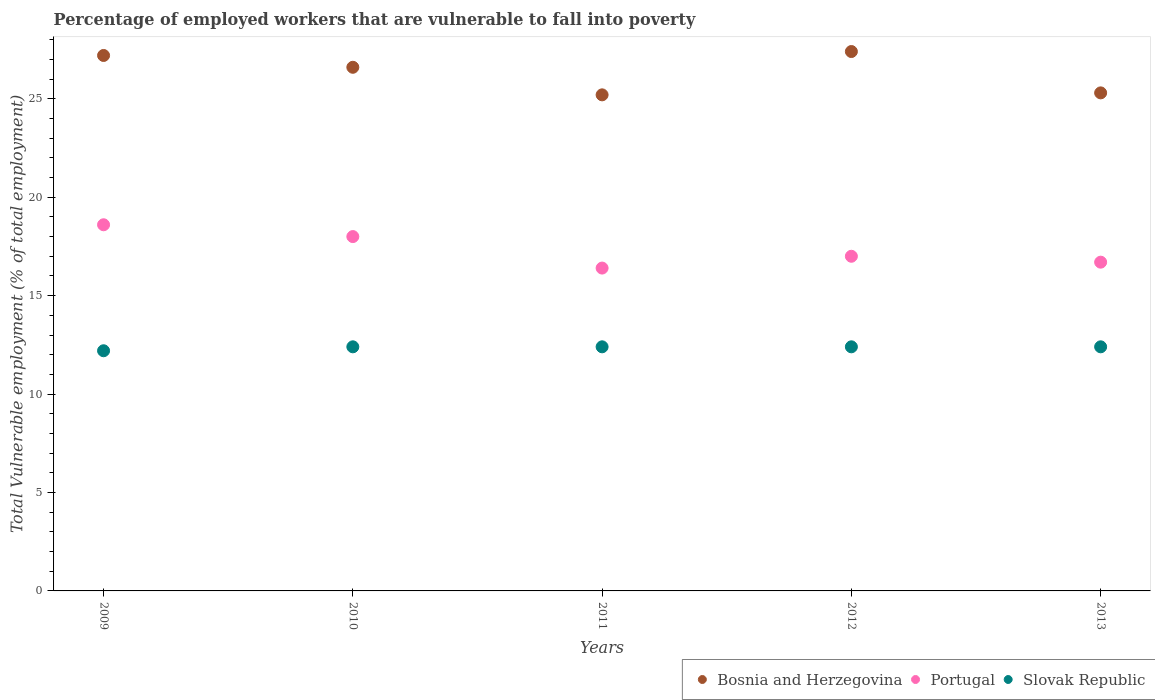How many different coloured dotlines are there?
Your answer should be compact. 3. Is the number of dotlines equal to the number of legend labels?
Give a very brief answer. Yes. What is the percentage of employed workers who are vulnerable to fall into poverty in Bosnia and Herzegovina in 2010?
Provide a succinct answer. 26.6. Across all years, what is the maximum percentage of employed workers who are vulnerable to fall into poverty in Portugal?
Keep it short and to the point. 18.6. Across all years, what is the minimum percentage of employed workers who are vulnerable to fall into poverty in Slovak Republic?
Offer a very short reply. 12.2. In which year was the percentage of employed workers who are vulnerable to fall into poverty in Slovak Republic minimum?
Your response must be concise. 2009. What is the total percentage of employed workers who are vulnerable to fall into poverty in Slovak Republic in the graph?
Your answer should be very brief. 61.8. What is the difference between the percentage of employed workers who are vulnerable to fall into poverty in Bosnia and Herzegovina in 2012 and that in 2013?
Make the answer very short. 2.1. What is the difference between the percentage of employed workers who are vulnerable to fall into poverty in Slovak Republic in 2010 and the percentage of employed workers who are vulnerable to fall into poverty in Portugal in 2009?
Make the answer very short. -6.2. What is the average percentage of employed workers who are vulnerable to fall into poverty in Bosnia and Herzegovina per year?
Your response must be concise. 26.34. In the year 2010, what is the difference between the percentage of employed workers who are vulnerable to fall into poverty in Portugal and percentage of employed workers who are vulnerable to fall into poverty in Bosnia and Herzegovina?
Your answer should be very brief. -8.6. What is the ratio of the percentage of employed workers who are vulnerable to fall into poverty in Slovak Republic in 2012 to that in 2013?
Keep it short and to the point. 1. What is the difference between the highest and the second highest percentage of employed workers who are vulnerable to fall into poverty in Bosnia and Herzegovina?
Keep it short and to the point. 0.2. What is the difference between the highest and the lowest percentage of employed workers who are vulnerable to fall into poverty in Bosnia and Herzegovina?
Make the answer very short. 2.2. In how many years, is the percentage of employed workers who are vulnerable to fall into poverty in Portugal greater than the average percentage of employed workers who are vulnerable to fall into poverty in Portugal taken over all years?
Give a very brief answer. 2. Is the sum of the percentage of employed workers who are vulnerable to fall into poverty in Slovak Republic in 2012 and 2013 greater than the maximum percentage of employed workers who are vulnerable to fall into poverty in Portugal across all years?
Your answer should be very brief. Yes. Is it the case that in every year, the sum of the percentage of employed workers who are vulnerable to fall into poverty in Bosnia and Herzegovina and percentage of employed workers who are vulnerable to fall into poverty in Slovak Republic  is greater than the percentage of employed workers who are vulnerable to fall into poverty in Portugal?
Your answer should be compact. Yes. How many dotlines are there?
Provide a succinct answer. 3. How many legend labels are there?
Your response must be concise. 3. How are the legend labels stacked?
Your answer should be very brief. Horizontal. What is the title of the graph?
Your answer should be compact. Percentage of employed workers that are vulnerable to fall into poverty. What is the label or title of the Y-axis?
Your answer should be compact. Total Vulnerable employment (% of total employment). What is the Total Vulnerable employment (% of total employment) in Bosnia and Herzegovina in 2009?
Your answer should be compact. 27.2. What is the Total Vulnerable employment (% of total employment) of Portugal in 2009?
Make the answer very short. 18.6. What is the Total Vulnerable employment (% of total employment) of Slovak Republic in 2009?
Your answer should be compact. 12.2. What is the Total Vulnerable employment (% of total employment) in Bosnia and Herzegovina in 2010?
Ensure brevity in your answer.  26.6. What is the Total Vulnerable employment (% of total employment) of Portugal in 2010?
Your answer should be very brief. 18. What is the Total Vulnerable employment (% of total employment) of Slovak Republic in 2010?
Provide a short and direct response. 12.4. What is the Total Vulnerable employment (% of total employment) in Bosnia and Herzegovina in 2011?
Provide a succinct answer. 25.2. What is the Total Vulnerable employment (% of total employment) of Portugal in 2011?
Give a very brief answer. 16.4. What is the Total Vulnerable employment (% of total employment) in Slovak Republic in 2011?
Offer a terse response. 12.4. What is the Total Vulnerable employment (% of total employment) in Bosnia and Herzegovina in 2012?
Keep it short and to the point. 27.4. What is the Total Vulnerable employment (% of total employment) in Slovak Republic in 2012?
Ensure brevity in your answer.  12.4. What is the Total Vulnerable employment (% of total employment) of Bosnia and Herzegovina in 2013?
Offer a terse response. 25.3. What is the Total Vulnerable employment (% of total employment) in Portugal in 2013?
Ensure brevity in your answer.  16.7. What is the Total Vulnerable employment (% of total employment) in Slovak Republic in 2013?
Offer a very short reply. 12.4. Across all years, what is the maximum Total Vulnerable employment (% of total employment) in Bosnia and Herzegovina?
Ensure brevity in your answer.  27.4. Across all years, what is the maximum Total Vulnerable employment (% of total employment) of Portugal?
Keep it short and to the point. 18.6. Across all years, what is the maximum Total Vulnerable employment (% of total employment) in Slovak Republic?
Provide a succinct answer. 12.4. Across all years, what is the minimum Total Vulnerable employment (% of total employment) of Bosnia and Herzegovina?
Ensure brevity in your answer.  25.2. Across all years, what is the minimum Total Vulnerable employment (% of total employment) of Portugal?
Your response must be concise. 16.4. Across all years, what is the minimum Total Vulnerable employment (% of total employment) of Slovak Republic?
Offer a very short reply. 12.2. What is the total Total Vulnerable employment (% of total employment) in Bosnia and Herzegovina in the graph?
Ensure brevity in your answer.  131.7. What is the total Total Vulnerable employment (% of total employment) of Portugal in the graph?
Provide a short and direct response. 86.7. What is the total Total Vulnerable employment (% of total employment) in Slovak Republic in the graph?
Your answer should be compact. 61.8. What is the difference between the Total Vulnerable employment (% of total employment) in Bosnia and Herzegovina in 2009 and that in 2010?
Keep it short and to the point. 0.6. What is the difference between the Total Vulnerable employment (% of total employment) of Portugal in 2009 and that in 2010?
Your response must be concise. 0.6. What is the difference between the Total Vulnerable employment (% of total employment) of Slovak Republic in 2009 and that in 2010?
Ensure brevity in your answer.  -0.2. What is the difference between the Total Vulnerable employment (% of total employment) of Bosnia and Herzegovina in 2009 and that in 2012?
Keep it short and to the point. -0.2. What is the difference between the Total Vulnerable employment (% of total employment) of Portugal in 2009 and that in 2012?
Provide a succinct answer. 1.6. What is the difference between the Total Vulnerable employment (% of total employment) of Slovak Republic in 2009 and that in 2012?
Provide a succinct answer. -0.2. What is the difference between the Total Vulnerable employment (% of total employment) of Bosnia and Herzegovina in 2009 and that in 2013?
Your answer should be very brief. 1.9. What is the difference between the Total Vulnerable employment (% of total employment) in Portugal in 2009 and that in 2013?
Your answer should be very brief. 1.9. What is the difference between the Total Vulnerable employment (% of total employment) in Slovak Republic in 2009 and that in 2013?
Provide a succinct answer. -0.2. What is the difference between the Total Vulnerable employment (% of total employment) of Bosnia and Herzegovina in 2010 and that in 2011?
Offer a terse response. 1.4. What is the difference between the Total Vulnerable employment (% of total employment) in Slovak Republic in 2010 and that in 2011?
Offer a very short reply. 0. What is the difference between the Total Vulnerable employment (% of total employment) of Portugal in 2010 and that in 2012?
Offer a very short reply. 1. What is the difference between the Total Vulnerable employment (% of total employment) in Bosnia and Herzegovina in 2010 and that in 2013?
Ensure brevity in your answer.  1.3. What is the difference between the Total Vulnerable employment (% of total employment) of Slovak Republic in 2010 and that in 2013?
Offer a very short reply. 0. What is the difference between the Total Vulnerable employment (% of total employment) of Portugal in 2011 and that in 2013?
Provide a short and direct response. -0.3. What is the difference between the Total Vulnerable employment (% of total employment) of Slovak Republic in 2011 and that in 2013?
Provide a succinct answer. 0. What is the difference between the Total Vulnerable employment (% of total employment) in Bosnia and Herzegovina in 2012 and that in 2013?
Provide a succinct answer. 2.1. What is the difference between the Total Vulnerable employment (% of total employment) in Slovak Republic in 2012 and that in 2013?
Ensure brevity in your answer.  0. What is the difference between the Total Vulnerable employment (% of total employment) in Bosnia and Herzegovina in 2009 and the Total Vulnerable employment (% of total employment) in Slovak Republic in 2010?
Offer a terse response. 14.8. What is the difference between the Total Vulnerable employment (% of total employment) in Portugal in 2009 and the Total Vulnerable employment (% of total employment) in Slovak Republic in 2010?
Your answer should be very brief. 6.2. What is the difference between the Total Vulnerable employment (% of total employment) of Bosnia and Herzegovina in 2009 and the Total Vulnerable employment (% of total employment) of Portugal in 2011?
Your response must be concise. 10.8. What is the difference between the Total Vulnerable employment (% of total employment) of Bosnia and Herzegovina in 2009 and the Total Vulnerable employment (% of total employment) of Slovak Republic in 2011?
Your answer should be compact. 14.8. What is the difference between the Total Vulnerable employment (% of total employment) in Portugal in 2009 and the Total Vulnerable employment (% of total employment) in Slovak Republic in 2011?
Your answer should be compact. 6.2. What is the difference between the Total Vulnerable employment (% of total employment) in Portugal in 2009 and the Total Vulnerable employment (% of total employment) in Slovak Republic in 2012?
Your answer should be very brief. 6.2. What is the difference between the Total Vulnerable employment (% of total employment) in Bosnia and Herzegovina in 2009 and the Total Vulnerable employment (% of total employment) in Slovak Republic in 2013?
Your answer should be very brief. 14.8. What is the difference between the Total Vulnerable employment (% of total employment) in Bosnia and Herzegovina in 2010 and the Total Vulnerable employment (% of total employment) in Slovak Republic in 2011?
Your response must be concise. 14.2. What is the difference between the Total Vulnerable employment (% of total employment) in Bosnia and Herzegovina in 2010 and the Total Vulnerable employment (% of total employment) in Portugal in 2012?
Provide a short and direct response. 9.6. What is the difference between the Total Vulnerable employment (% of total employment) of Bosnia and Herzegovina in 2010 and the Total Vulnerable employment (% of total employment) of Slovak Republic in 2012?
Ensure brevity in your answer.  14.2. What is the difference between the Total Vulnerable employment (% of total employment) in Bosnia and Herzegovina in 2011 and the Total Vulnerable employment (% of total employment) in Portugal in 2012?
Your answer should be very brief. 8.2. What is the difference between the Total Vulnerable employment (% of total employment) of Bosnia and Herzegovina in 2011 and the Total Vulnerable employment (% of total employment) of Slovak Republic in 2013?
Offer a terse response. 12.8. What is the difference between the Total Vulnerable employment (% of total employment) in Portugal in 2011 and the Total Vulnerable employment (% of total employment) in Slovak Republic in 2013?
Your answer should be compact. 4. What is the difference between the Total Vulnerable employment (% of total employment) in Portugal in 2012 and the Total Vulnerable employment (% of total employment) in Slovak Republic in 2013?
Your answer should be very brief. 4.6. What is the average Total Vulnerable employment (% of total employment) of Bosnia and Herzegovina per year?
Your response must be concise. 26.34. What is the average Total Vulnerable employment (% of total employment) in Portugal per year?
Your answer should be very brief. 17.34. What is the average Total Vulnerable employment (% of total employment) in Slovak Republic per year?
Your answer should be compact. 12.36. In the year 2009, what is the difference between the Total Vulnerable employment (% of total employment) in Bosnia and Herzegovina and Total Vulnerable employment (% of total employment) in Portugal?
Offer a terse response. 8.6. In the year 2009, what is the difference between the Total Vulnerable employment (% of total employment) in Portugal and Total Vulnerable employment (% of total employment) in Slovak Republic?
Give a very brief answer. 6.4. In the year 2010, what is the difference between the Total Vulnerable employment (% of total employment) of Bosnia and Herzegovina and Total Vulnerable employment (% of total employment) of Slovak Republic?
Offer a very short reply. 14.2. In the year 2011, what is the difference between the Total Vulnerable employment (% of total employment) in Bosnia and Herzegovina and Total Vulnerable employment (% of total employment) in Portugal?
Your answer should be very brief. 8.8. In the year 2011, what is the difference between the Total Vulnerable employment (% of total employment) in Bosnia and Herzegovina and Total Vulnerable employment (% of total employment) in Slovak Republic?
Ensure brevity in your answer.  12.8. In the year 2011, what is the difference between the Total Vulnerable employment (% of total employment) of Portugal and Total Vulnerable employment (% of total employment) of Slovak Republic?
Your response must be concise. 4. In the year 2012, what is the difference between the Total Vulnerable employment (% of total employment) in Bosnia and Herzegovina and Total Vulnerable employment (% of total employment) in Slovak Republic?
Give a very brief answer. 15. In the year 2013, what is the difference between the Total Vulnerable employment (% of total employment) of Bosnia and Herzegovina and Total Vulnerable employment (% of total employment) of Slovak Republic?
Keep it short and to the point. 12.9. What is the ratio of the Total Vulnerable employment (% of total employment) in Bosnia and Herzegovina in 2009 to that in 2010?
Ensure brevity in your answer.  1.02. What is the ratio of the Total Vulnerable employment (% of total employment) of Slovak Republic in 2009 to that in 2010?
Ensure brevity in your answer.  0.98. What is the ratio of the Total Vulnerable employment (% of total employment) of Bosnia and Herzegovina in 2009 to that in 2011?
Make the answer very short. 1.08. What is the ratio of the Total Vulnerable employment (% of total employment) in Portugal in 2009 to that in 2011?
Give a very brief answer. 1.13. What is the ratio of the Total Vulnerable employment (% of total employment) of Slovak Republic in 2009 to that in 2011?
Offer a very short reply. 0.98. What is the ratio of the Total Vulnerable employment (% of total employment) of Portugal in 2009 to that in 2012?
Your answer should be compact. 1.09. What is the ratio of the Total Vulnerable employment (% of total employment) of Slovak Republic in 2009 to that in 2012?
Keep it short and to the point. 0.98. What is the ratio of the Total Vulnerable employment (% of total employment) of Bosnia and Herzegovina in 2009 to that in 2013?
Keep it short and to the point. 1.08. What is the ratio of the Total Vulnerable employment (% of total employment) in Portugal in 2009 to that in 2013?
Offer a very short reply. 1.11. What is the ratio of the Total Vulnerable employment (% of total employment) of Slovak Republic in 2009 to that in 2013?
Offer a very short reply. 0.98. What is the ratio of the Total Vulnerable employment (% of total employment) of Bosnia and Herzegovina in 2010 to that in 2011?
Make the answer very short. 1.06. What is the ratio of the Total Vulnerable employment (% of total employment) of Portugal in 2010 to that in 2011?
Provide a succinct answer. 1.1. What is the ratio of the Total Vulnerable employment (% of total employment) in Slovak Republic in 2010 to that in 2011?
Your answer should be very brief. 1. What is the ratio of the Total Vulnerable employment (% of total employment) of Bosnia and Herzegovina in 2010 to that in 2012?
Provide a short and direct response. 0.97. What is the ratio of the Total Vulnerable employment (% of total employment) in Portugal in 2010 to that in 2012?
Provide a succinct answer. 1.06. What is the ratio of the Total Vulnerable employment (% of total employment) of Slovak Republic in 2010 to that in 2012?
Offer a terse response. 1. What is the ratio of the Total Vulnerable employment (% of total employment) of Bosnia and Herzegovina in 2010 to that in 2013?
Provide a short and direct response. 1.05. What is the ratio of the Total Vulnerable employment (% of total employment) of Portugal in 2010 to that in 2013?
Your response must be concise. 1.08. What is the ratio of the Total Vulnerable employment (% of total employment) in Bosnia and Herzegovina in 2011 to that in 2012?
Keep it short and to the point. 0.92. What is the ratio of the Total Vulnerable employment (% of total employment) in Portugal in 2011 to that in 2012?
Your answer should be compact. 0.96. What is the ratio of the Total Vulnerable employment (% of total employment) of Bosnia and Herzegovina in 2011 to that in 2013?
Offer a very short reply. 1. What is the ratio of the Total Vulnerable employment (% of total employment) of Portugal in 2011 to that in 2013?
Offer a terse response. 0.98. What is the ratio of the Total Vulnerable employment (% of total employment) of Bosnia and Herzegovina in 2012 to that in 2013?
Ensure brevity in your answer.  1.08. What is the ratio of the Total Vulnerable employment (% of total employment) of Portugal in 2012 to that in 2013?
Your response must be concise. 1.02. What is the difference between the highest and the second highest Total Vulnerable employment (% of total employment) in Portugal?
Provide a succinct answer. 0.6. What is the difference between the highest and the second highest Total Vulnerable employment (% of total employment) of Slovak Republic?
Offer a terse response. 0. What is the difference between the highest and the lowest Total Vulnerable employment (% of total employment) of Portugal?
Offer a very short reply. 2.2. What is the difference between the highest and the lowest Total Vulnerable employment (% of total employment) of Slovak Republic?
Your answer should be compact. 0.2. 